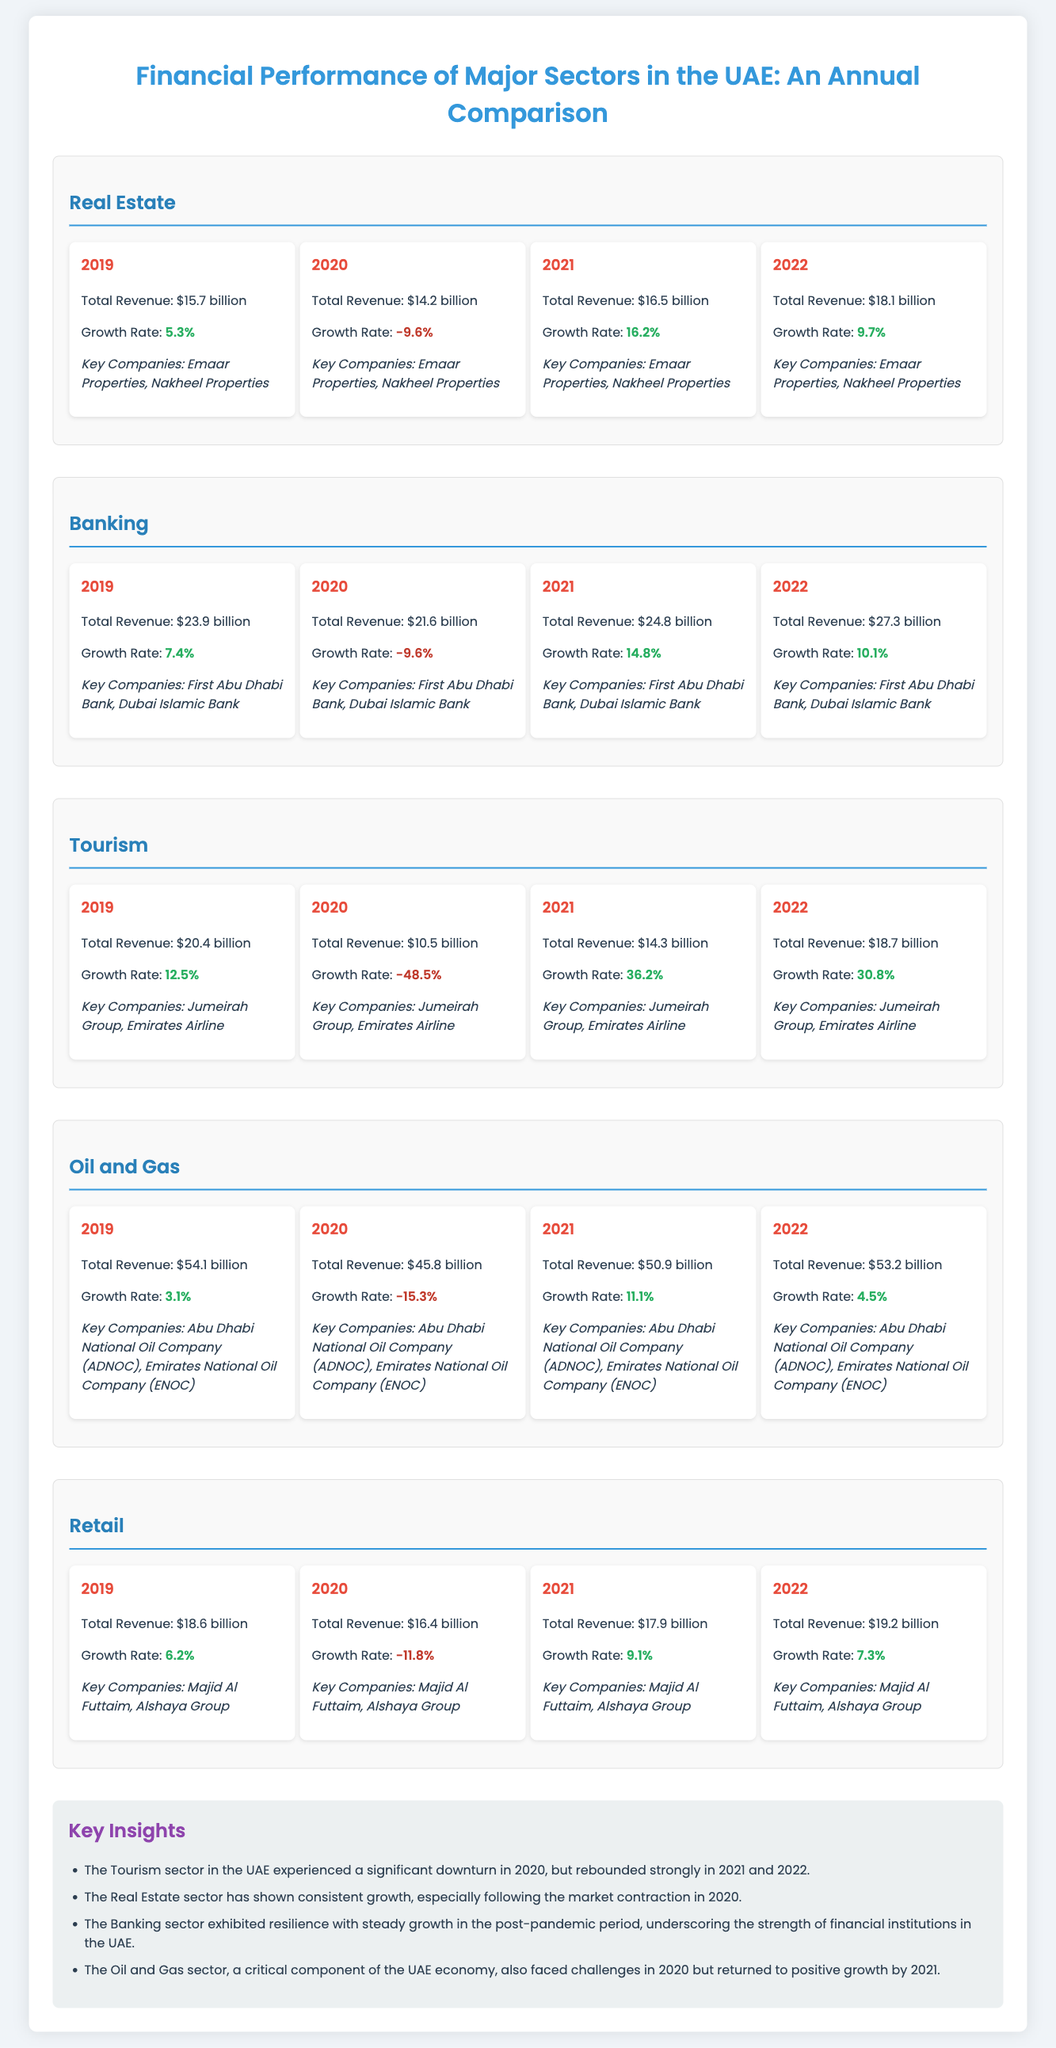What is the total revenue of the Real Estate sector in 2022? The total revenue in 2022 for the Real Estate sector is mentioned explicitly in the document.
Answer: $18.1 billion What was the growth rate of the Banking sector in 2021? The growth rate is provided for each year under the Banking sector and can be directly cited.
Answer: 14.8% Which key companies are associated with the Tourism sector? The document lists the key companies for each sector; the key companies for Tourism can be directly found.
Answer: Jumeirah Group, Emirates Airline What year had the lowest revenue for the Oil and Gas sector? By comparing the total revenue figures from each year, we identify the lowest one for the Oil and Gas sector.
Answer: 2020 Which sector had the highest total revenue in 2019? A quick review of the total revenue amounts for each sector in 2019 reveals which was the highest.
Answer: Oil and Gas What is a key insight provided in the document? The insights section summarizes important findings about the performance of different sectors, which can be quoted.
Answer: The Tourism sector in the UAE experienced a significant downturn in 2020, but rebounded strongly in 2021 and 2022 